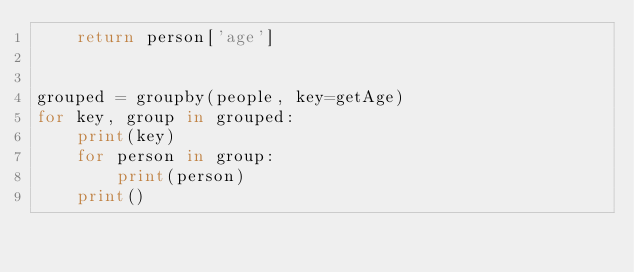Convert code to text. <code><loc_0><loc_0><loc_500><loc_500><_Python_>    return person['age']


grouped = groupby(people, key=getAge)
for key, group in grouped:
    print(key)
    for person in group:
        print(person)
    print()
</code> 